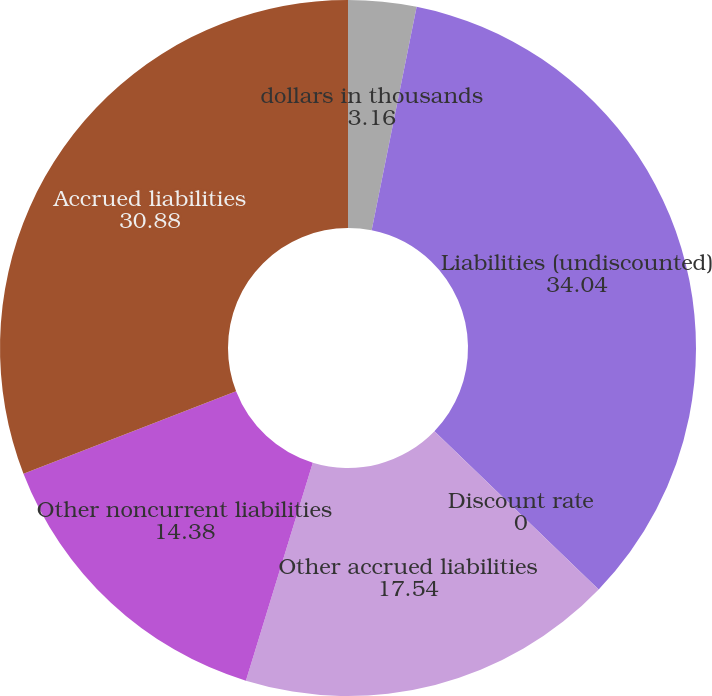Convert chart to OTSL. <chart><loc_0><loc_0><loc_500><loc_500><pie_chart><fcel>dollars in thousands<fcel>Liabilities (undiscounted)<fcel>Discount rate<fcel>Other accrued liabilities<fcel>Other noncurrent liabilities<fcel>Accrued liabilities<nl><fcel>3.16%<fcel>34.04%<fcel>0.0%<fcel>17.54%<fcel>14.38%<fcel>30.88%<nl></chart> 